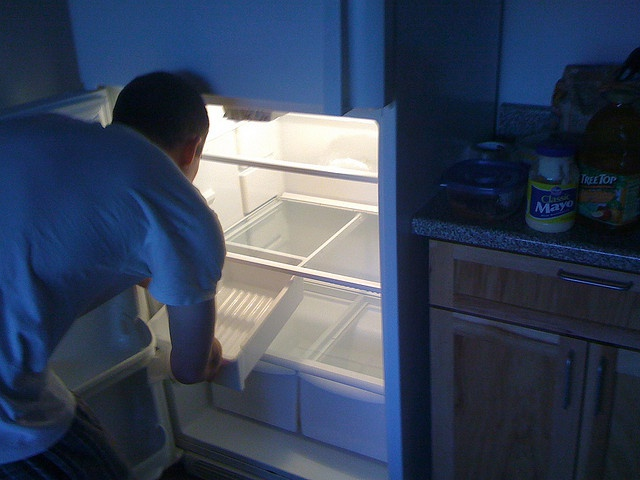Describe the objects in this image and their specific colors. I can see refrigerator in black, blue, darkgray, and ivory tones, people in black, navy, blue, and darkblue tones, bottle in black, navy, darkblue, and gray tones, and bottle in black, navy, darkblue, and darkgreen tones in this image. 